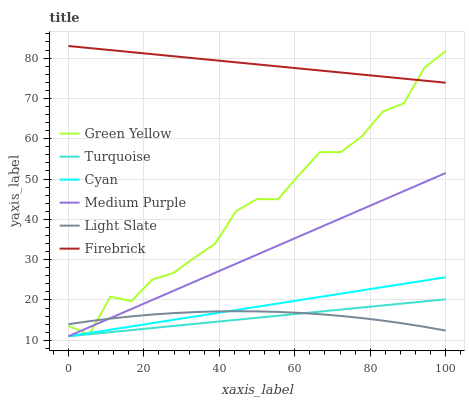Does Turquoise have the minimum area under the curve?
Answer yes or no. Yes. Does Firebrick have the maximum area under the curve?
Answer yes or no. Yes. Does Light Slate have the minimum area under the curve?
Answer yes or no. No. Does Light Slate have the maximum area under the curve?
Answer yes or no. No. Is Turquoise the smoothest?
Answer yes or no. Yes. Is Green Yellow the roughest?
Answer yes or no. Yes. Is Light Slate the smoothest?
Answer yes or no. No. Is Light Slate the roughest?
Answer yes or no. No. Does Turquoise have the lowest value?
Answer yes or no. Yes. Does Light Slate have the lowest value?
Answer yes or no. No. Does Firebrick have the highest value?
Answer yes or no. Yes. Does Light Slate have the highest value?
Answer yes or no. No. Is Light Slate less than Firebrick?
Answer yes or no. Yes. Is Firebrick greater than Medium Purple?
Answer yes or no. Yes. Does Green Yellow intersect Firebrick?
Answer yes or no. Yes. Is Green Yellow less than Firebrick?
Answer yes or no. No. Is Green Yellow greater than Firebrick?
Answer yes or no. No. Does Light Slate intersect Firebrick?
Answer yes or no. No. 